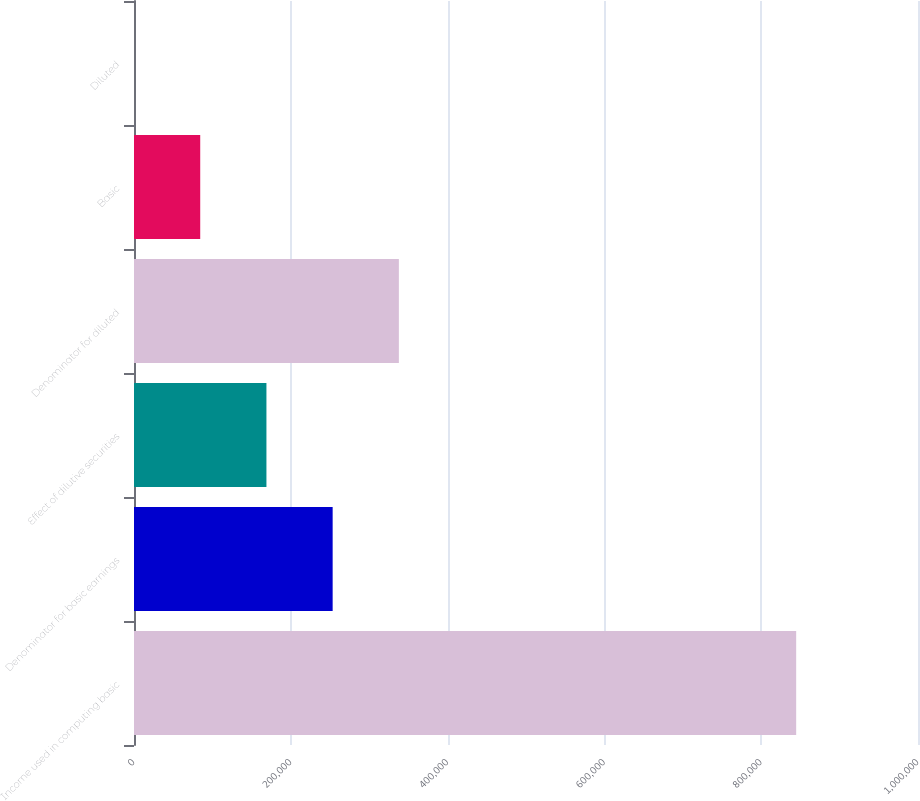Convert chart to OTSL. <chart><loc_0><loc_0><loc_500><loc_500><bar_chart><fcel>Income used in computing basic<fcel>Denominator for basic earnings<fcel>Effect of dilutive securities<fcel>Denominator for diluted<fcel>Basic<fcel>Diluted<nl><fcel>844611<fcel>253386<fcel>168925<fcel>337847<fcel>84464.6<fcel>3.88<nl></chart> 